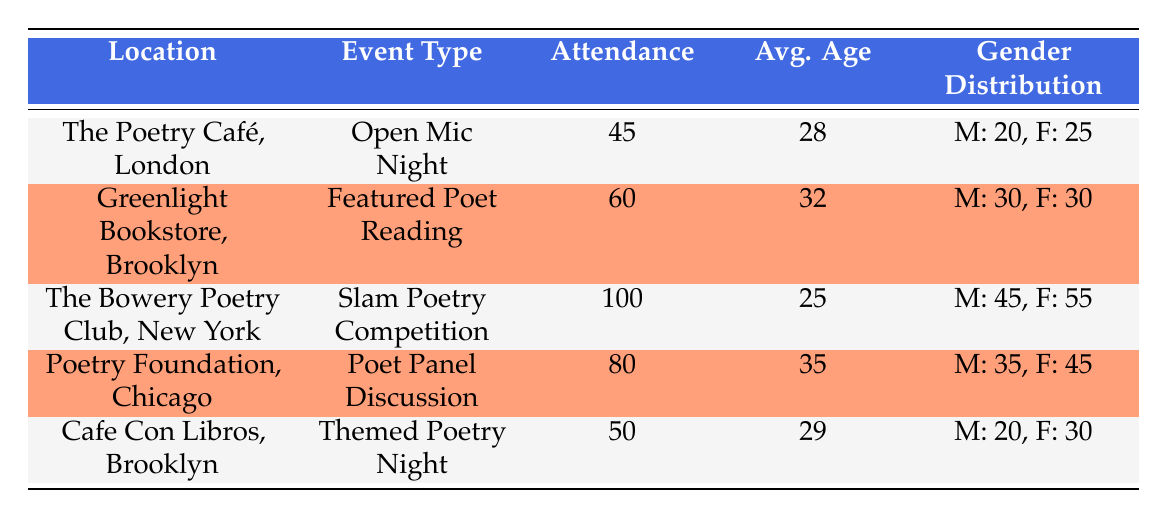What was the attendance at The Bowery Poetry Club in New York? The table indicates that the attendance at The Bowery Poetry Club for the Slam Poetry Competition is 100.
Answer: 100 What is the average age of attendees at the Poetry Foundation in Chicago? The table shows that the average age at the Poetry Foundation for the Poet Panel Discussion is 35.
Answer: 35 Was there a higher male or female attendance at the Open Mic Night in London? The table provides gender distribution: 20 males and 25 females attended, indicating that female attendance was higher.
Answer: No What is the total attendance for the events held in Brooklyn? The attendance for the events in Brooklyn are 60 (Greenlight Bookstore) and 50 (Cafe Con Libros), summing these gives 60 + 50 = 110.
Answer: 110 Which event had the highest attendance and what was that number? The Bowery Poetry Club's Slam Poetry Competition had the highest attendance at 100. This is the maximum value in the attendance column.
Answer: 100 How many more females than males attended the Slam Poetry Competition? For the Slam Poetry Competition, there were 55 females and 45 males. The difference is 55 - 45 = 10 more females.
Answer: 10 What is the average age of attendees across all events? To find the average, sum the average ages: 28 + 32 + 25 + 35 + 29 = 149. Then divide by the number of events, which is 5: 149 / 5 = 29.8.
Answer: 29.8 Is the gender distribution at Cafe Con Libros more skewed towards females than males? The gender distribution shows 20 males and 30 females, indicating it is skewed towards females since 30 > 20.
Answer: Yes What is the percentage of male attendees at the Poet Panel Discussion? The total attendance was 80, with 35 males. The percentage is (35 / 80) * 100 = 43.75%.
Answer: 43.75% 